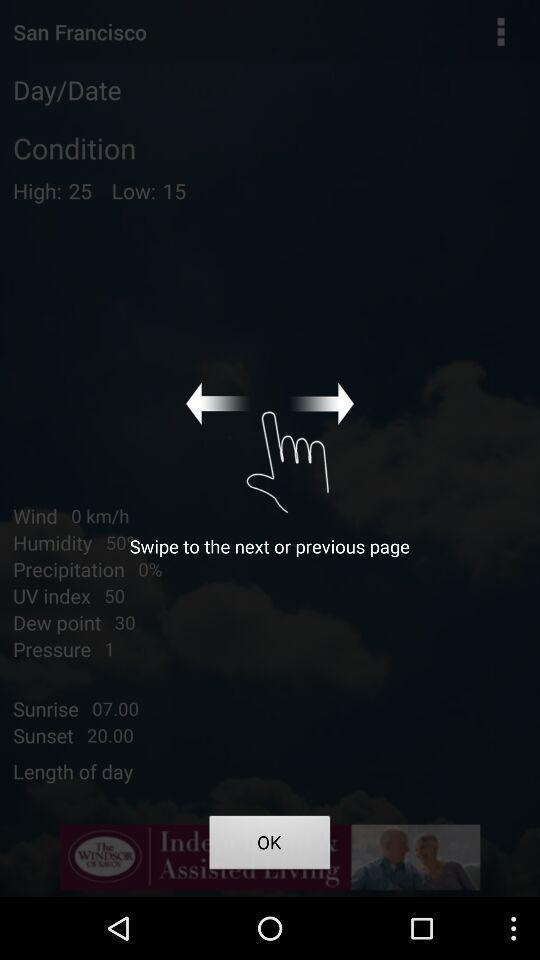Explain the elements present in this screenshot. Swipe up page of a weather forecast app. 